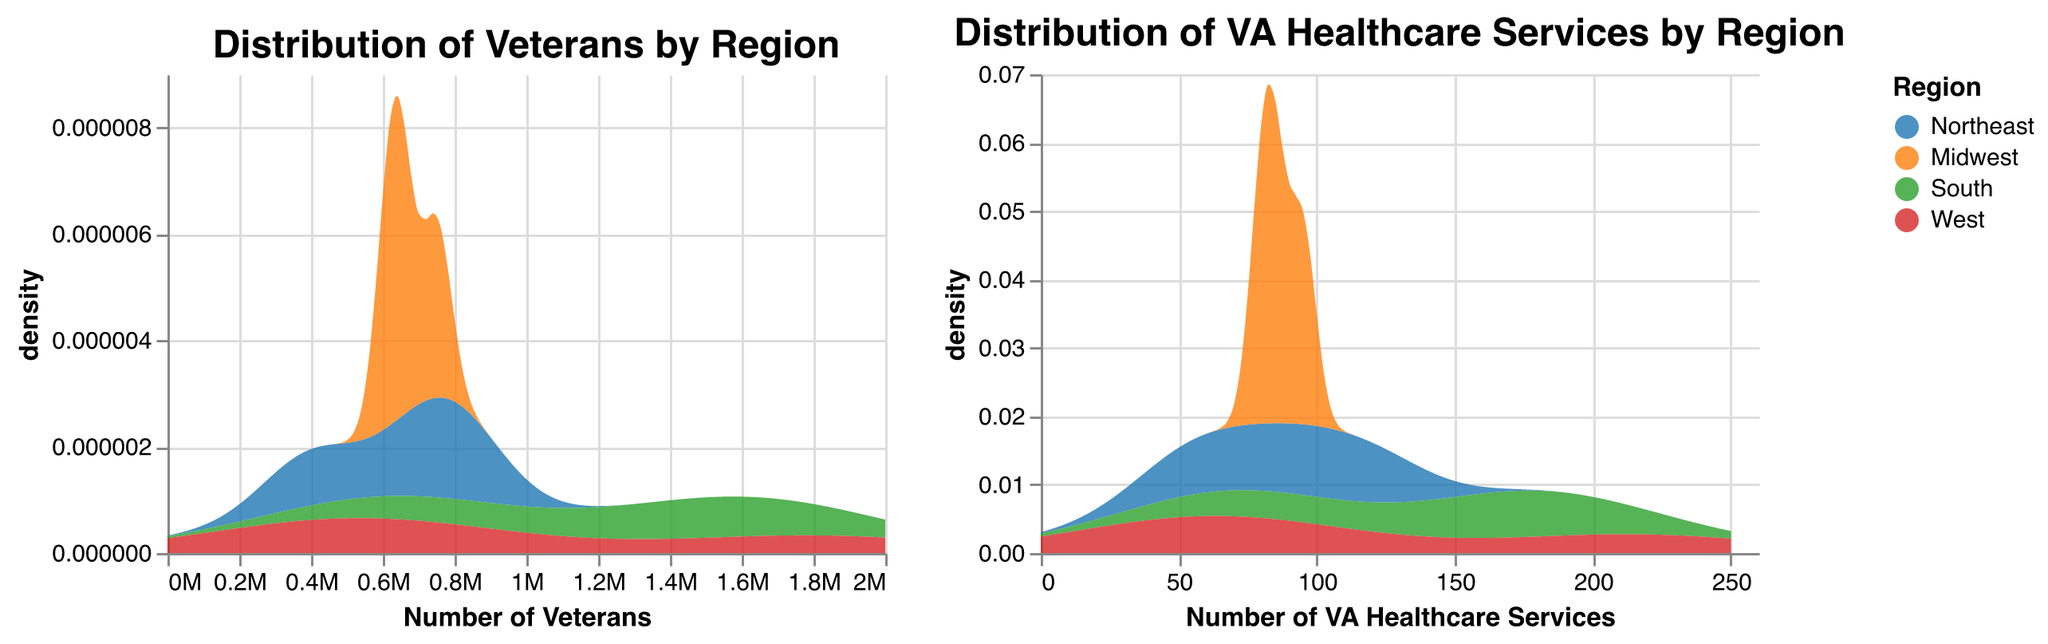What's the title of the first plot? The title of a plot is typically at the top of the visual, inside or above the boundary of the plot. Referring to the rendered figure, the first plot's title reads "Distribution of Veterans by Region".
Answer: Distribution of Veterans by Region What does the x-axis represent in the second plot? The x-axis labels the quantity being measured horizontally across the plot. In the second plot, it is labeled as "Number of VA Healthcare Services".
Answer: Number of VA Healthcare Services Which region has the highest density of Veterans in the first plot? To find this, observe the peak of the density curves in the first plot. The region with the tallest peak represents the highest density. The South has the highest density peak.
Answer: South By observing the plots, which region has more VA healthcare services, the Midwest or the West? Compare the density peaks of the Midwest and the West regions in the second plot. The West has a higher peak, indicating more VA healthcare services.
Answer: West What's the range of the x-axis values in the first plot? Identify the minimum and maximum values on the x-axis of the first plot. The range provided is from 0 to 2,000,000.
Answer: 0 to 2,000,000 Is the density of VA healthcare services higher in the South or the Northeast? Observing the second plot, compare the density peaks for the South and the Northeast. The South has a taller peak, indicating a higher density.
Answer: South Explain how to identify which regions are color-coded in the plots. To identify the regions, look at the legend which maps each color to a specific region. Blue represents the Northeast, orange for the Midwest, green for the South, and red for the West.
Answer: Blue (Northeast), orange (Midwest), green (South), red (West) Does California have more Veterans or VA healthcare services? Refer to the data values provided: California (West) has 1,800,000 veterans and 215 VA healthcare services. Compare these values directly.
Answer: Veterans From the first plot, which region seems to have the most consistent (narrowest spread) distribution of Veterans? Examine the width of each region's density curve in the first plot. The Midwest has the narrowest spread, indicating the most consistent distribution.
Answer: Midwest 